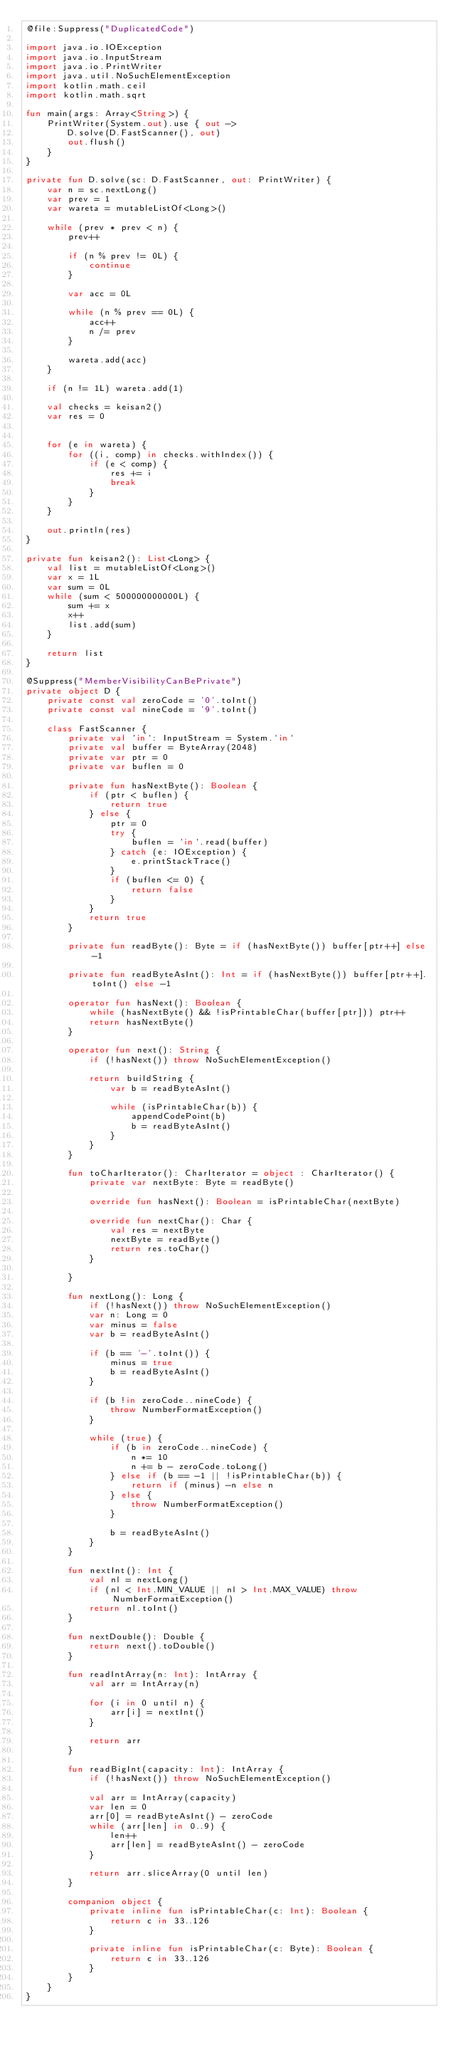Convert code to text. <code><loc_0><loc_0><loc_500><loc_500><_Kotlin_>@file:Suppress("DuplicatedCode")

import java.io.IOException
import java.io.InputStream
import java.io.PrintWriter
import java.util.NoSuchElementException
import kotlin.math.ceil
import kotlin.math.sqrt

fun main(args: Array<String>) {
    PrintWriter(System.out).use { out ->
        D.solve(D.FastScanner(), out)
        out.flush()
    }
}

private fun D.solve(sc: D.FastScanner, out: PrintWriter) {
    var n = sc.nextLong()
    var prev = 1
    var wareta = mutableListOf<Long>()

    while (prev * prev < n) {
        prev++

        if (n % prev != 0L) {
            continue
        }

        var acc = 0L

        while (n % prev == 0L) {
            acc++
            n /= prev
        }

        wareta.add(acc)
    }

    if (n != 1L) wareta.add(1)

    val checks = keisan2()
    var res = 0


    for (e in wareta) {
        for ((i, comp) in checks.withIndex()) {
            if (e < comp) {
                res += i
                break
            }
        }
    }

    out.println(res)
}

private fun keisan2(): List<Long> {
    val list = mutableListOf<Long>()
    var x = 1L
    var sum = 0L
    while (sum < 500000000000L) {
        sum += x
        x++
        list.add(sum)
    }

    return list
}

@Suppress("MemberVisibilityCanBePrivate")
private object D {
    private const val zeroCode = '0'.toInt()
    private const val nineCode = '9'.toInt()

    class FastScanner {
        private val `in`: InputStream = System.`in`
        private val buffer = ByteArray(2048)
        private var ptr = 0
        private var buflen = 0

        private fun hasNextByte(): Boolean {
            if (ptr < buflen) {
                return true
            } else {
                ptr = 0
                try {
                    buflen = `in`.read(buffer)
                } catch (e: IOException) {
                    e.printStackTrace()
                }
                if (buflen <= 0) {
                    return false
                }
            }
            return true
        }

        private fun readByte(): Byte = if (hasNextByte()) buffer[ptr++] else -1

        private fun readByteAsInt(): Int = if (hasNextByte()) buffer[ptr++].toInt() else -1

        operator fun hasNext(): Boolean {
            while (hasNextByte() && !isPrintableChar(buffer[ptr])) ptr++
            return hasNextByte()
        }

        operator fun next(): String {
            if (!hasNext()) throw NoSuchElementException()

            return buildString {
                var b = readByteAsInt()

                while (isPrintableChar(b)) {
                    appendCodePoint(b)
                    b = readByteAsInt()
                }
            }
        }

        fun toCharIterator(): CharIterator = object : CharIterator() {
            private var nextByte: Byte = readByte()

            override fun hasNext(): Boolean = isPrintableChar(nextByte)

            override fun nextChar(): Char {
                val res = nextByte
                nextByte = readByte()
                return res.toChar()
            }

        }

        fun nextLong(): Long {
            if (!hasNext()) throw NoSuchElementException()
            var n: Long = 0
            var minus = false
            var b = readByteAsInt()

            if (b == '-'.toInt()) {
                minus = true
                b = readByteAsInt()
            }

            if (b !in zeroCode..nineCode) {
                throw NumberFormatException()
            }

            while (true) {
                if (b in zeroCode..nineCode) {
                    n *= 10
                    n += b - zeroCode.toLong()
                } else if (b == -1 || !isPrintableChar(b)) {
                    return if (minus) -n else n
                } else {
                    throw NumberFormatException()
                }

                b = readByteAsInt()
            }
        }

        fun nextInt(): Int {
            val nl = nextLong()
            if (nl < Int.MIN_VALUE || nl > Int.MAX_VALUE) throw NumberFormatException()
            return nl.toInt()
        }

        fun nextDouble(): Double {
            return next().toDouble()
        }

        fun readIntArray(n: Int): IntArray {
            val arr = IntArray(n)

            for (i in 0 until n) {
                arr[i] = nextInt()
            }

            return arr
        }

        fun readBigInt(capacity: Int): IntArray {
            if (!hasNext()) throw NoSuchElementException()

            val arr = IntArray(capacity)
            var len = 0
            arr[0] = readByteAsInt() - zeroCode
            while (arr[len] in 0..9) {
                len++
                arr[len] = readByteAsInt() - zeroCode
            }

            return arr.sliceArray(0 until len)
        }

        companion object {
            private inline fun isPrintableChar(c: Int): Boolean {
                return c in 33..126
            }

            private inline fun isPrintableChar(c: Byte): Boolean {
                return c in 33..126
            }
        }
    }
}
</code> 